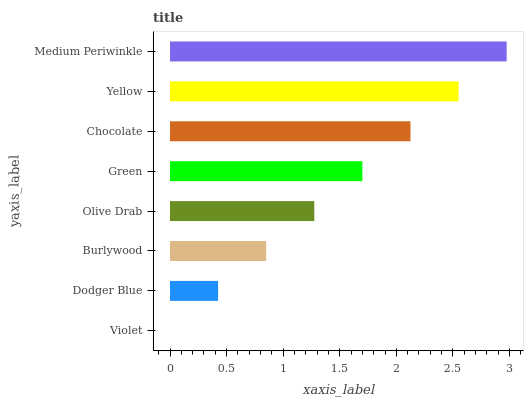Is Violet the minimum?
Answer yes or no. Yes. Is Medium Periwinkle the maximum?
Answer yes or no. Yes. Is Dodger Blue the minimum?
Answer yes or no. No. Is Dodger Blue the maximum?
Answer yes or no. No. Is Dodger Blue greater than Violet?
Answer yes or no. Yes. Is Violet less than Dodger Blue?
Answer yes or no. Yes. Is Violet greater than Dodger Blue?
Answer yes or no. No. Is Dodger Blue less than Violet?
Answer yes or no. No. Is Green the high median?
Answer yes or no. Yes. Is Olive Drab the low median?
Answer yes or no. Yes. Is Burlywood the high median?
Answer yes or no. No. Is Green the low median?
Answer yes or no. No. 